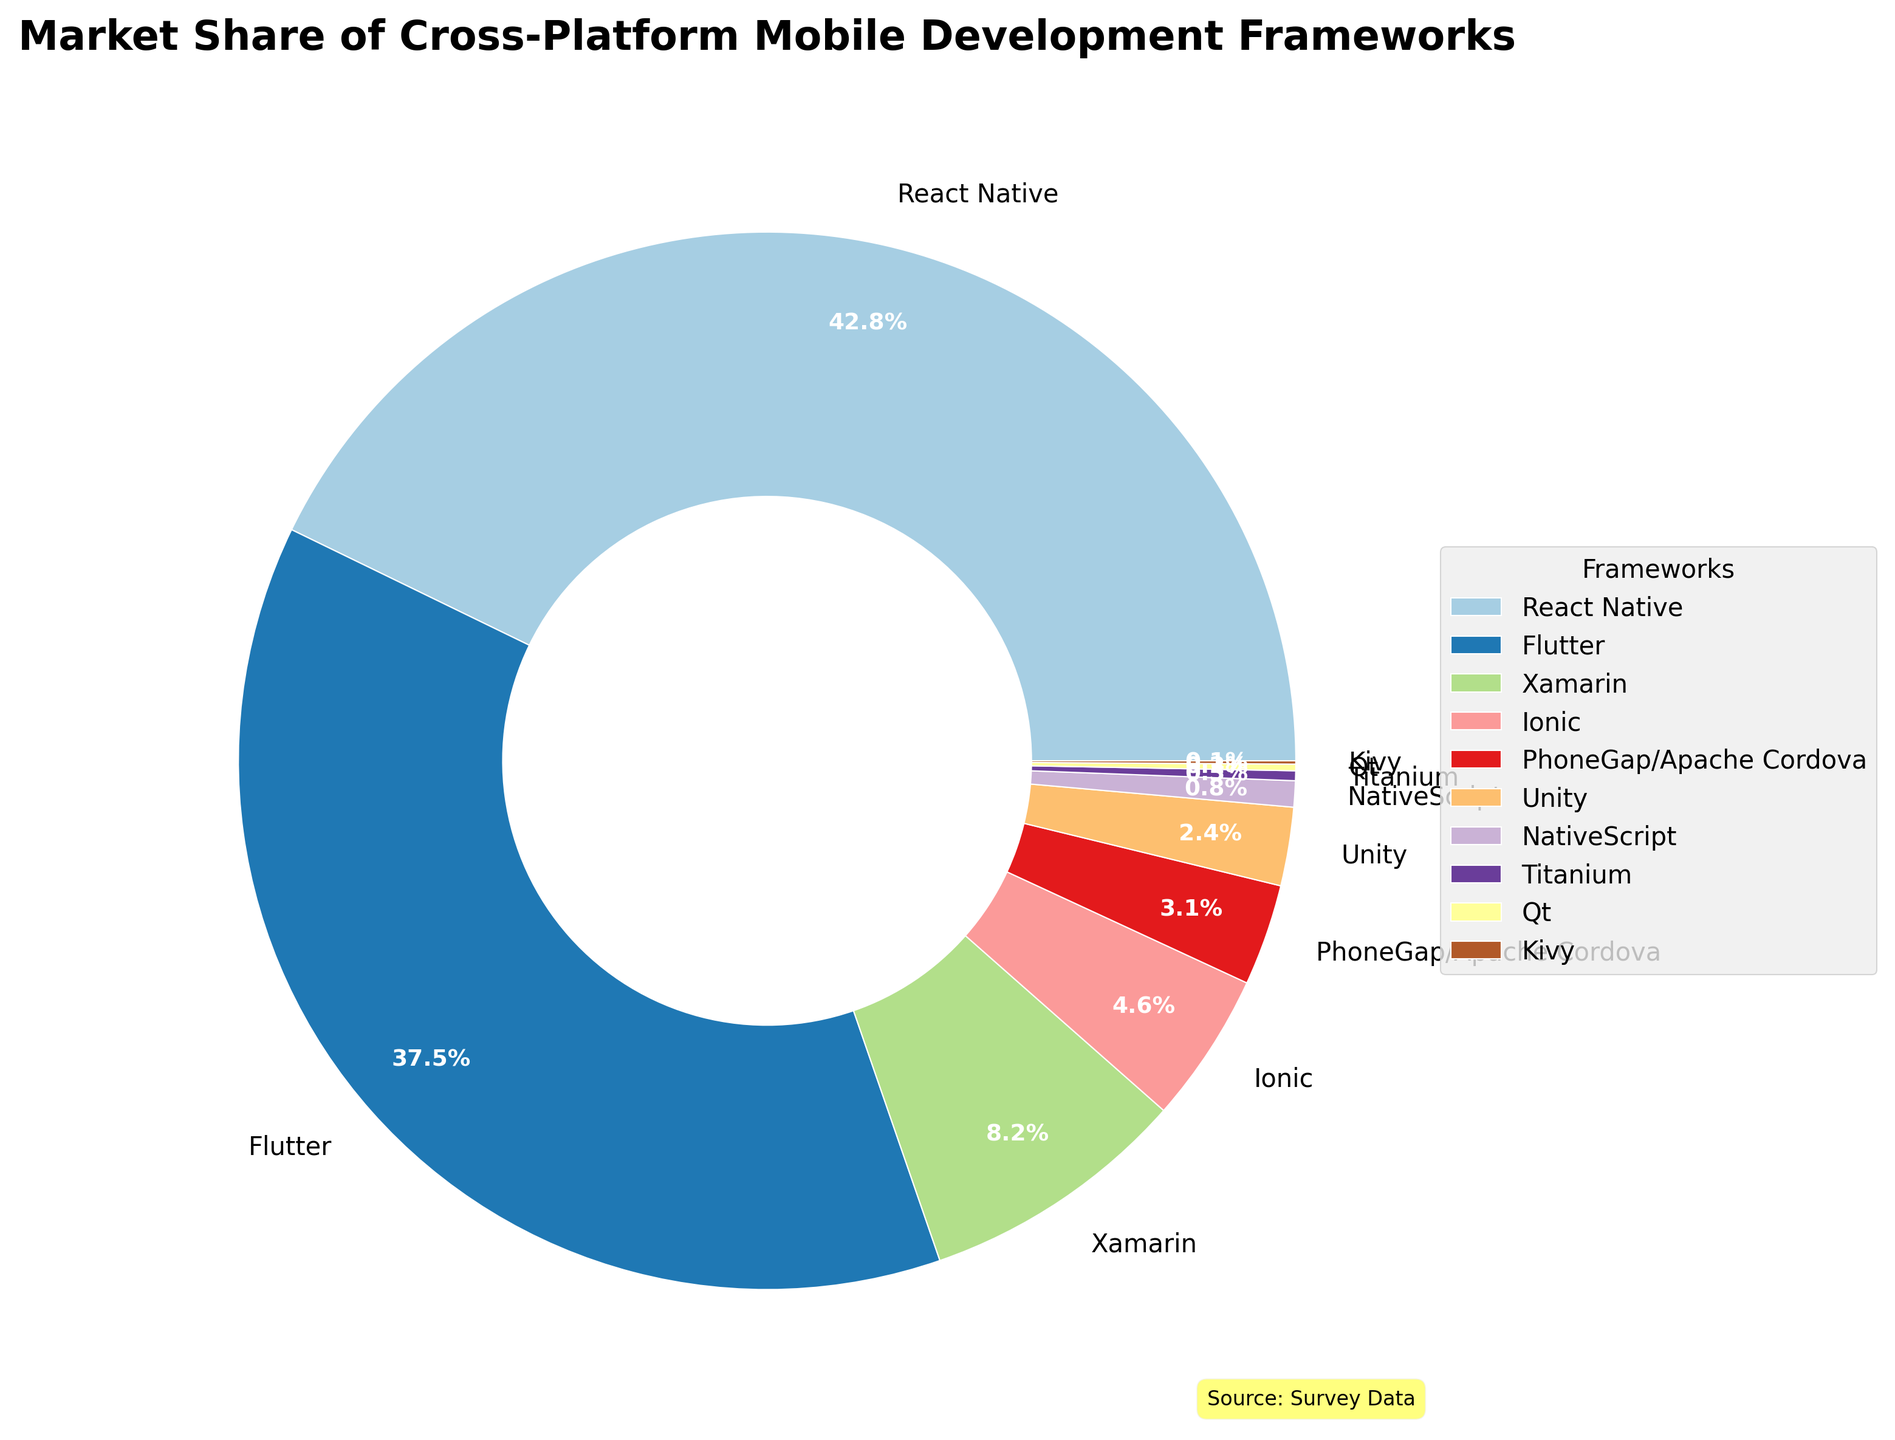What is the market share of React Native? React Native's market share is clearly labeled on the pie chart as 42.8%.
Answer: 42.8% Which framework has the smallest market share? By visually inspecting the pie chart, Kivy has the smallest slice of the pie, with a market share of 0.1%.
Answer: Kivy Compare the market share of Flutter and Xamarin. Which one is higher and by how much? Flutter has a market share of 37.5%, and Xamarin has 8.2%. The difference is 37.5% - 8.2% = 29.3%.
Answer: Flutter is higher by 29.3% What is the total market share of the top three frameworks? The top three frameworks are React Native (42.8%), Flutter (37.5%), and Xamarin (8.2%). Their total market share is 42.8 + 37.5 + 8.2 = 88.5%.
Answer: 88.5% Which framework has a higher market share, Ionic or PhoneGap/Apache Cordova? Ionic's market share is 4.6%, while PhoneGap/Apache Cordova’s is 3.1%; 4.6% > 3.1%.
Answer: Ionic What is the approximate visual size difference between React Native's and Unity's segments? React Native’s segment is significantly larger than Unity’s. React Native has 42.8% and Unity has 2.4%, which means React Native's segment is about 40.4% larger than Unity's.
Answer: React Native's segment is about 40.4% larger How much more market share does React Native have than Flutter? React Native’s market share is 42.8%, and Flutter’s is 37.5%. The difference is 42.8% - 37.5% = 5.3%.
Answer: 5.3% Compare the combined market share of frameworks with less than 1% share to that of Xamarin? The frameworks with less than 1% share are NativeScript (0.8%), Titanium (0.3%), Qt (0.2%), and Kivy (0.1%), summing up to 1.4%. Xamarin's share is 8.2%. 1.4% < 8.2%.
Answer: Xamarin has a larger share How many frameworks have a larger market share than Ionic? React Native, Flutter, and Xamarin all have a larger market share than Ionic. Therefore, the number is 3.
Answer: 3 What framework holds exactly half of Unity's market share? Unity has a market share of 2.4%. Half of that is 2.4 / 2 = 1.2%. None of the frameworks listed have a market share of exactly 1.2%.
Answer: None 